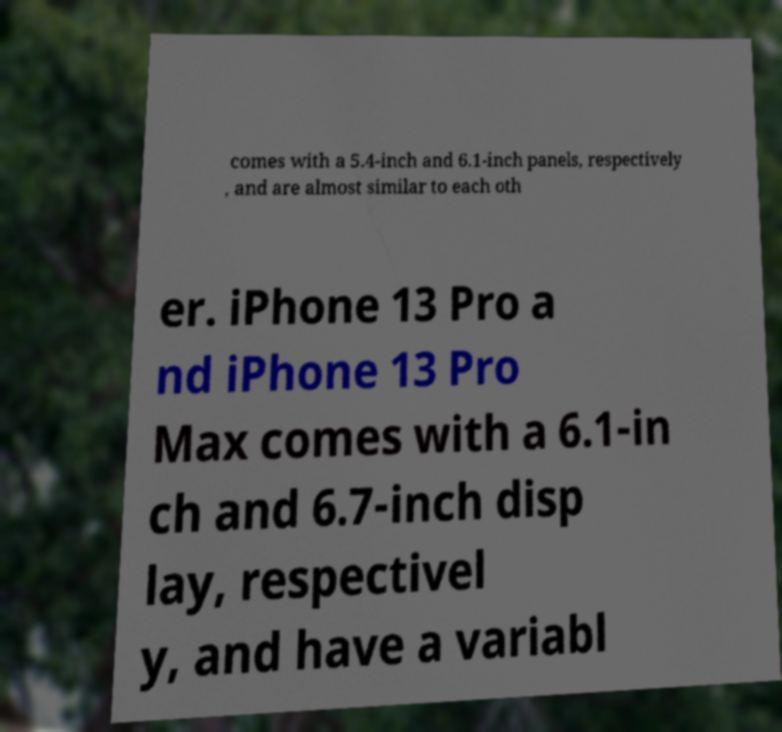Could you assist in decoding the text presented in this image and type it out clearly? comes with a 5.4-inch and 6.1-inch panels, respectively , and are almost similar to each oth er. iPhone 13 Pro a nd iPhone 13 Pro Max comes with a 6.1-in ch and 6.7-inch disp lay, respectivel y, and have a variabl 